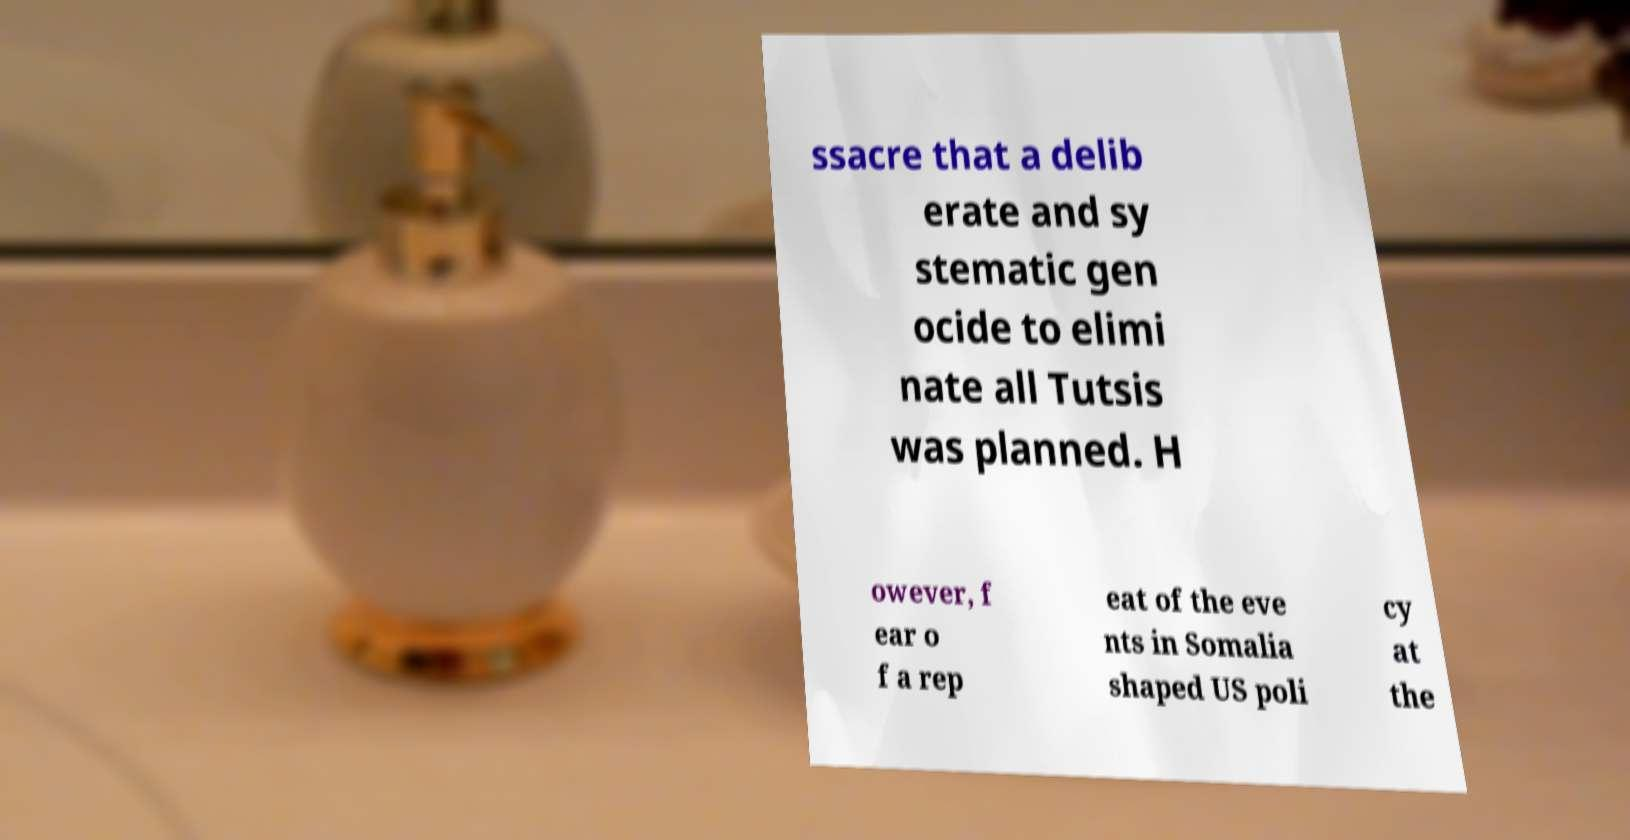Can you accurately transcribe the text from the provided image for me? ssacre that a delib erate and sy stematic gen ocide to elimi nate all Tutsis was planned. H owever, f ear o f a rep eat of the eve nts in Somalia shaped US poli cy at the 